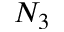<formula> <loc_0><loc_0><loc_500><loc_500>N _ { 3 }</formula> 